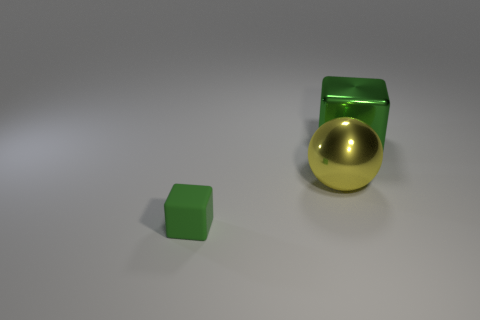Add 1 matte objects. How many objects exist? 4 Subtract all spheres. How many objects are left? 2 Add 2 small cubes. How many small cubes are left? 3 Add 2 metallic things. How many metallic things exist? 4 Subtract 0 yellow blocks. How many objects are left? 3 Subtract all yellow matte cylinders. Subtract all balls. How many objects are left? 2 